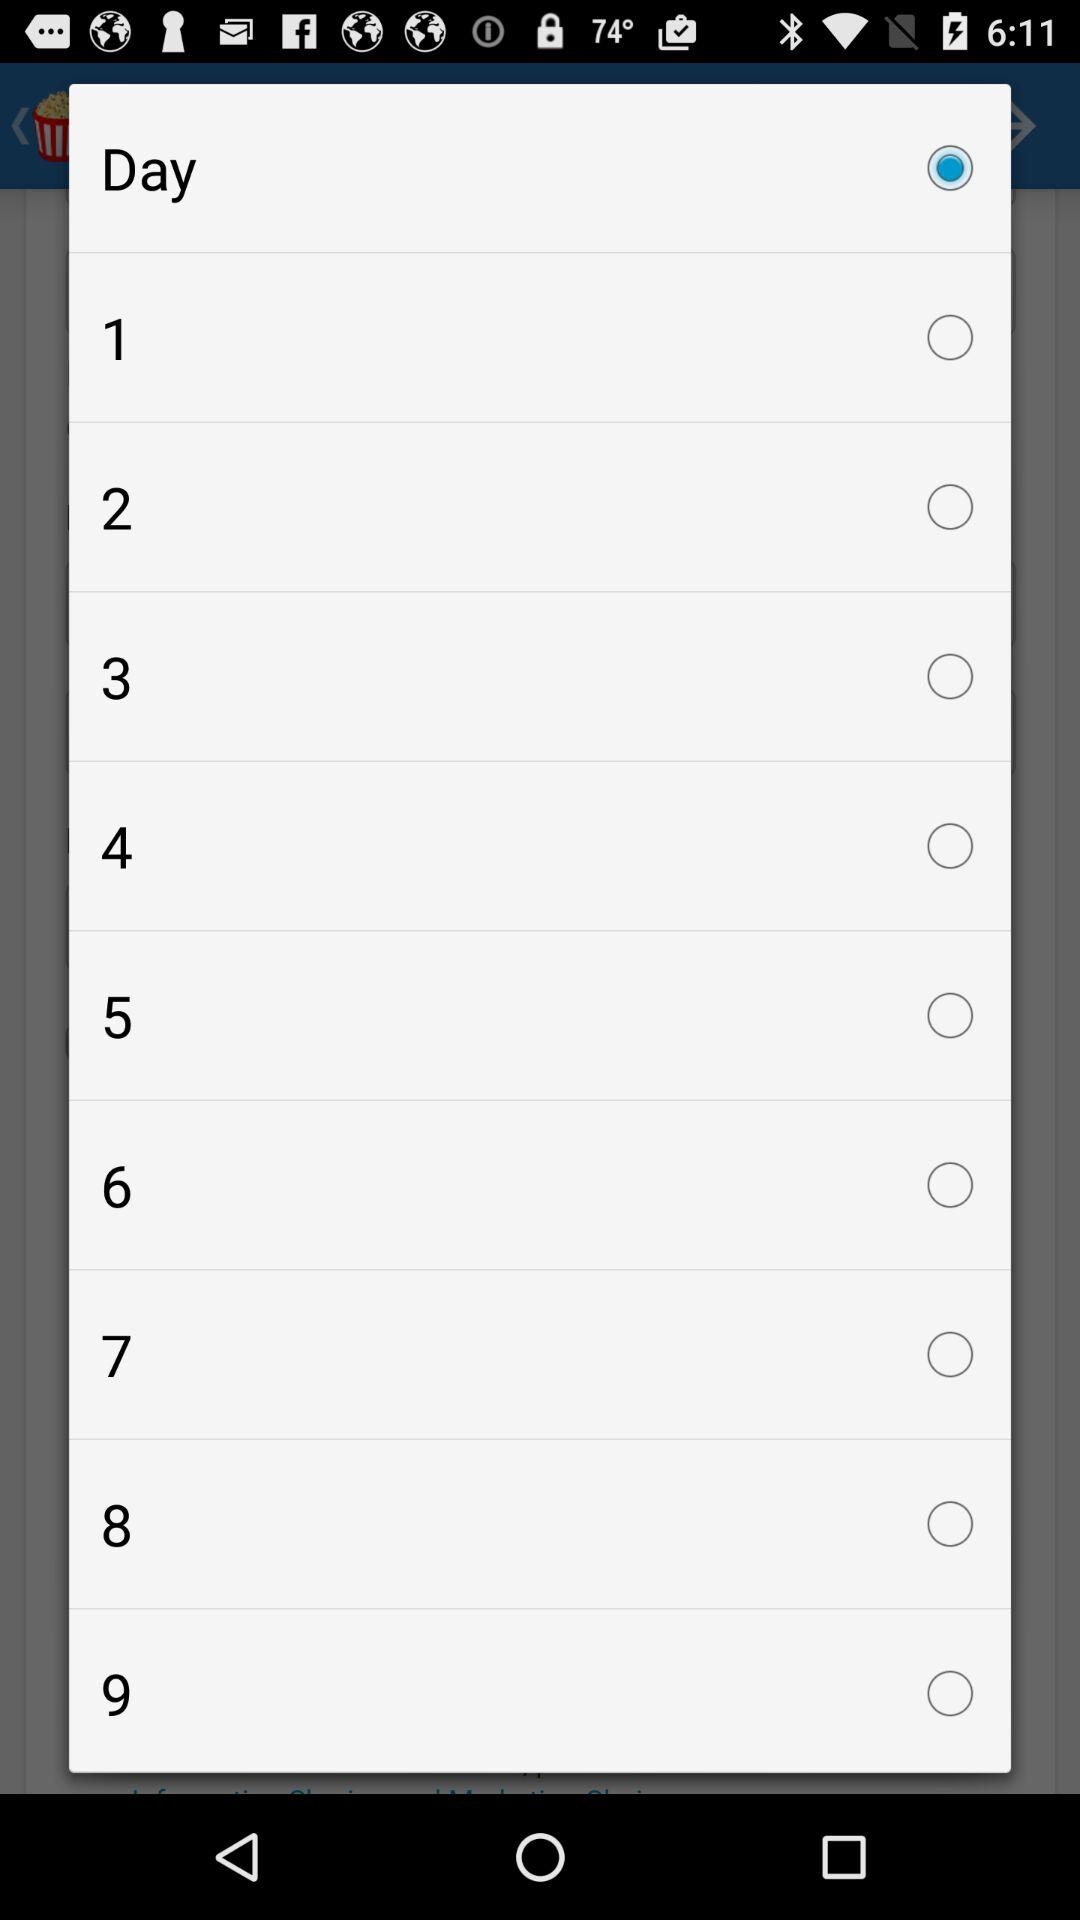What is the status of 1? The status of 1 is off. 